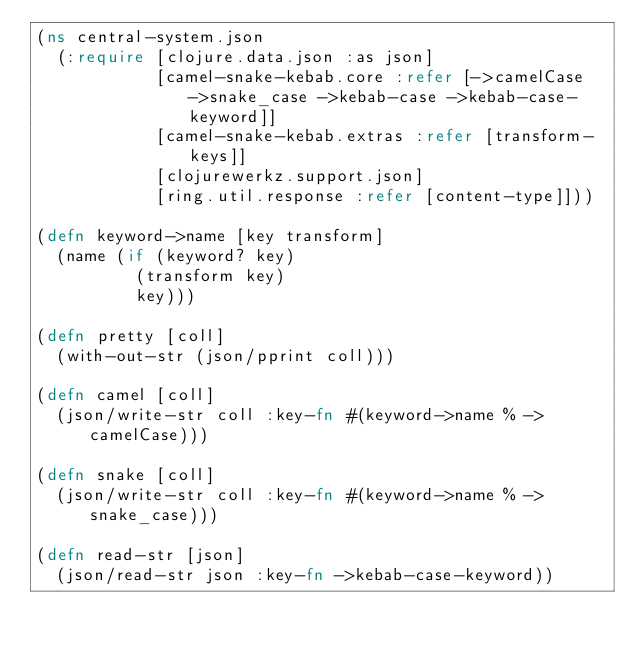<code> <loc_0><loc_0><loc_500><loc_500><_Clojure_>(ns central-system.json
  (:require [clojure.data.json :as json]
            [camel-snake-kebab.core :refer [->camelCase ->snake_case ->kebab-case ->kebab-case-keyword]]
            [camel-snake-kebab.extras :refer [transform-keys]]
            [clojurewerkz.support.json]
            [ring.util.response :refer [content-type]]))

(defn keyword->name [key transform]
  (name (if (keyword? key)
          (transform key)
          key)))

(defn pretty [coll]
  (with-out-str (json/pprint coll)))

(defn camel [coll]
  (json/write-str coll :key-fn #(keyword->name % ->camelCase)))

(defn snake [coll]
  (json/write-str coll :key-fn #(keyword->name % ->snake_case)))

(defn read-str [json]
  (json/read-str json :key-fn ->kebab-case-keyword))</code> 